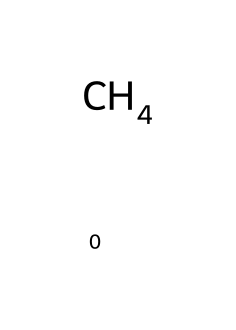What is the molecular formula of methane? The SMILES representation "C" indicates that the chemical consists of one carbon atom (C), and the hydrogen atoms can be inferred to be four in total based on standard valency rules. Therefore, the molecular formula is CH4.
Answer: CH4 How many hydrogen atoms are bonded to the carbon in methane? The structure from the SMILES representation shows one carbon atom surrounded by four total bonds to hydrogen atoms. Each bond signifies one hydrogen atom.
Answer: 4 What type of chemical is methane classified as? Methane is identified as a hydrocarbon due to its composition of hydrogen and carbon. Specifically, it is categorized as an alkane, reflecting its single bonds and saturated nature.
Answer: hydrocarbon What is the state of methane at room temperature? Methane is a gas at room temperature, consistent with its classification as a gaseous alkane. Room temperature conditions promote the gaseous state of methane.
Answer: gas What property of methane makes it a suitable fuel for heating? Methane has a high combustion efficiency, meaning it produces a significant amount of energy upon burning, which is a desirable characteristic for heating applications.
Answer: combustion efficiency How many total valence electrons are in methane? The carbon atom contributes four valence electrons, and each of the four hydrogen atoms provides one valence electron, resulting in a total of eight valence electrons in methane.
Answer: 8 